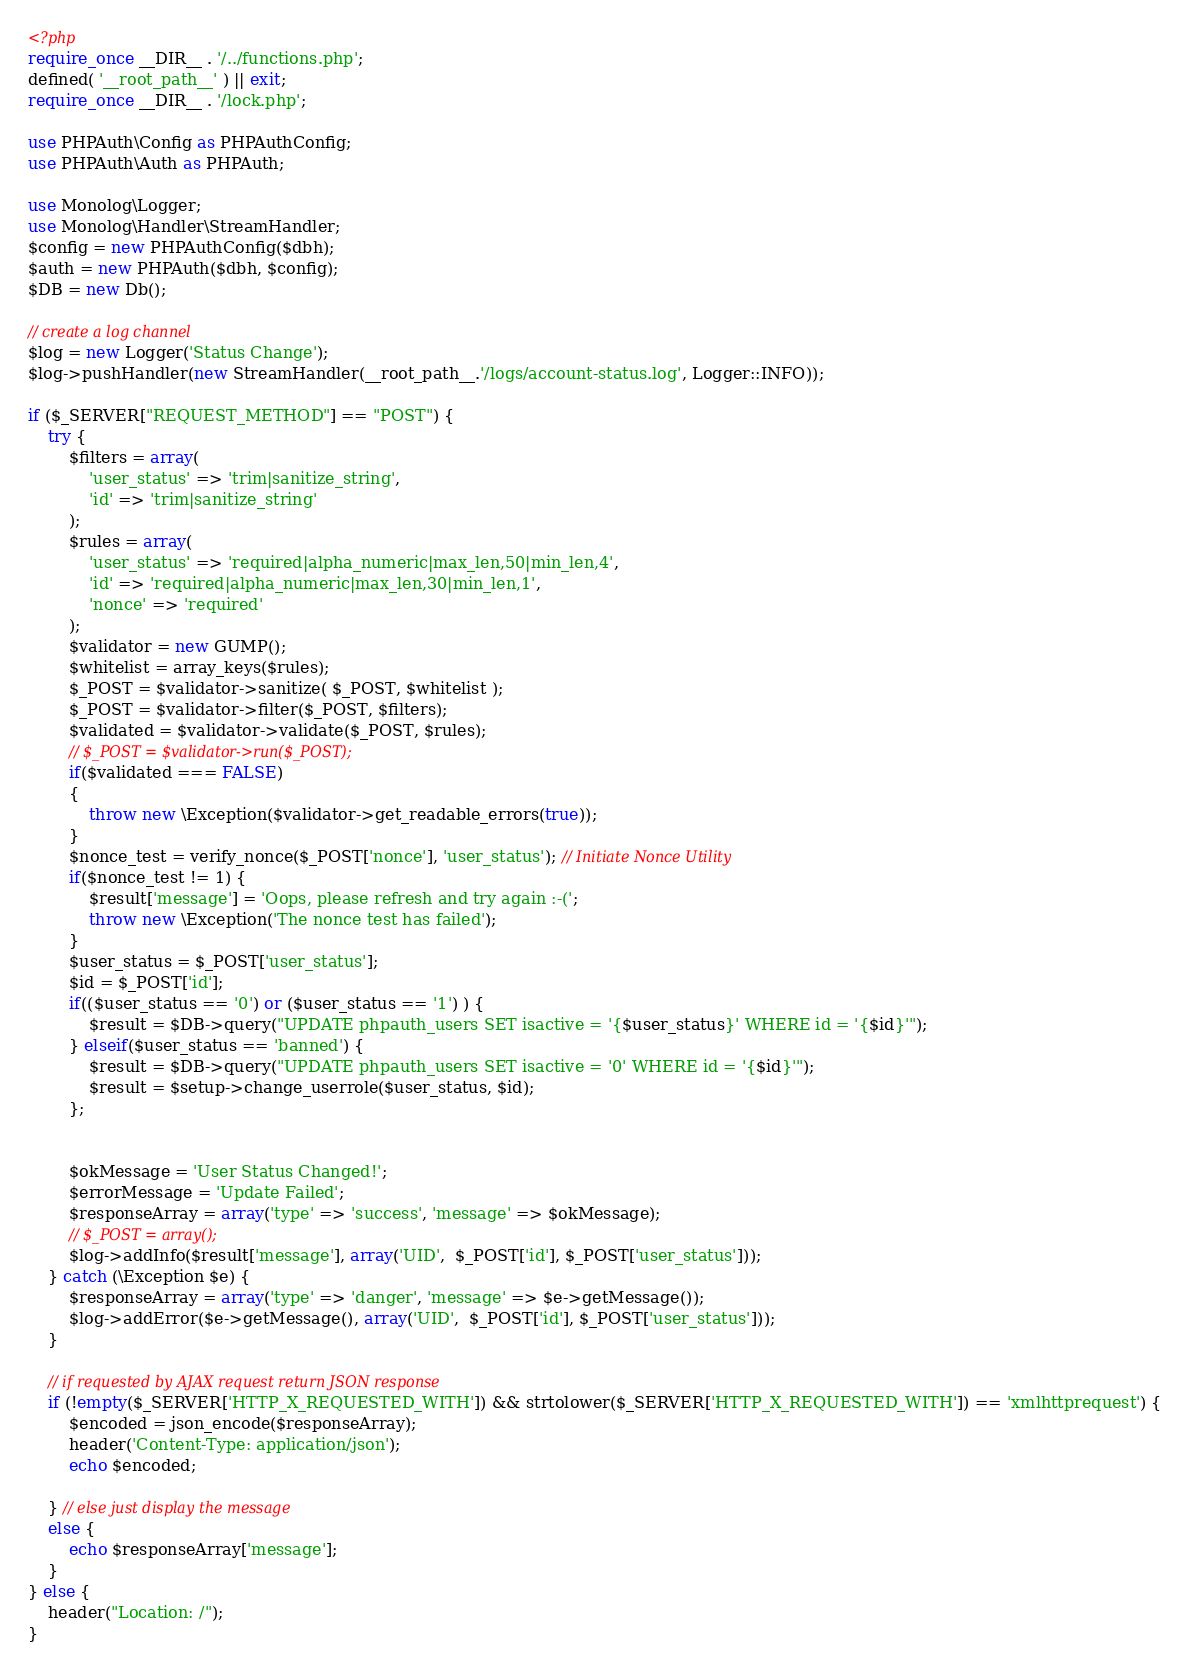<code> <loc_0><loc_0><loc_500><loc_500><_PHP_><?php
require_once __DIR__ . '/../functions.php';
defined( '__root_path__' ) || exit;
require_once __DIR__ . '/lock.php';

use PHPAuth\Config as PHPAuthConfig;
use PHPAuth\Auth as PHPAuth;

use Monolog\Logger;
use Monolog\Handler\StreamHandler;
$config = new PHPAuthConfig($dbh);
$auth = new PHPAuth($dbh, $config);
$DB = new Db();

// create a log channel
$log = new Logger('Status Change');
$log->pushHandler(new StreamHandler(__root_path__.'/logs/account-status.log', Logger::INFO));

if ($_SERVER["REQUEST_METHOD"] == "POST") {
    try {
        $filters = array(
            'user_status' => 'trim|sanitize_string',
            'id' => 'trim|sanitize_string'
        );
        $rules = array(
            'user_status' => 'required|alpha_numeric|max_len,50|min_len,4',
            'id' => 'required|alpha_numeric|max_len,30|min_len,1',
            'nonce' => 'required'
        );
        $validator = new GUMP();
        $whitelist = array_keys($rules);
        $_POST = $validator->sanitize( $_POST, $whitelist );
        $_POST = $validator->filter($_POST, $filters);
        $validated = $validator->validate($_POST, $rules);
        // $_POST = $validator->run($_POST);
        if($validated === FALSE)
        {
            throw new \Exception($validator->get_readable_errors(true));
        }
        $nonce_test = verify_nonce($_POST['nonce'], 'user_status'); // Initiate Nonce Utility
        if($nonce_test != 1) {
            $result['message'] = 'Oops, please refresh and try again :-(';
            throw new \Exception('The nonce test has failed');
        }
        $user_status = $_POST['user_status'];
        $id = $_POST['id'];
        if(($user_status == '0') or ($user_status == '1') ) {
            $result = $DB->query("UPDATE phpauth_users SET isactive = '{$user_status}' WHERE id = '{$id}'");
        } elseif($user_status == 'banned') {
            $result = $DB->query("UPDATE phpauth_users SET isactive = '0' WHERE id = '{$id}'");
            $result = $setup->change_userrole($user_status, $id);
        };


        $okMessage = 'User Status Changed!';
        $errorMessage = 'Update Failed';
        $responseArray = array('type' => 'success', 'message' => $okMessage);
        // $_POST = array();
        $log->addInfo($result['message'], array('UID',  $_POST['id'], $_POST['user_status']));
    } catch (\Exception $e) {
        $responseArray = array('type' => 'danger', 'message' => $e->getMessage());
        $log->addError($e->getMessage(), array('UID',  $_POST['id'], $_POST['user_status']));
    }

    // if requested by AJAX request return JSON response
    if (!empty($_SERVER['HTTP_X_REQUESTED_WITH']) && strtolower($_SERVER['HTTP_X_REQUESTED_WITH']) == 'xmlhttprequest') {
        $encoded = json_encode($responseArray);
        header('Content-Type: application/json');
        echo $encoded;

    } // else just display the message
    else {
        echo $responseArray['message'];
    }
} else {
    header("Location: /");
}
</code> 